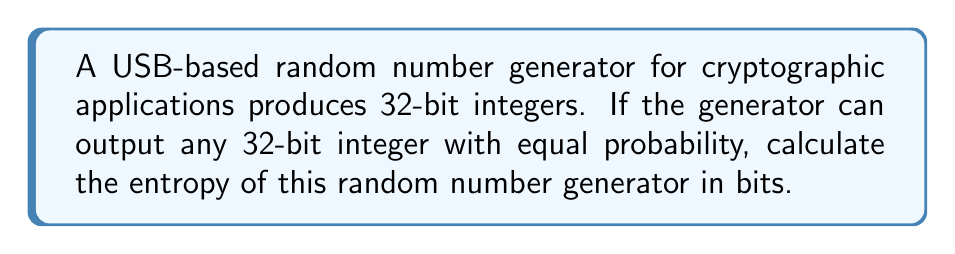Give your solution to this math problem. Let's approach this step-by-step:

1) Entropy is a measure of uncertainty or randomness in a system. For a discrete random variable, it's calculated using the formula:

   $$H = -\sum_{i=1}^n p_i \log_2(p_i)$$

   where $p_i$ is the probability of each possible outcome.

2) In this case, we have a 32-bit integer generator. This means there are $2^{32}$ possible outcomes (from 0 to $2^{32} - 1$).

3) The question states that each outcome has equal probability. So, the probability of each outcome is:

   $$p_i = \frac{1}{2^{32}}$$

4) Since all probabilities are equal, we can simplify our entropy calculation:

   $$H = -2^{32} \cdot \frac{1}{2^{32}} \log_2(\frac{1}{2^{32}})$$

5) Simplify:
   
   $$H = -\log_2(\frac{1}{2^{32}})$$

6) Using the logarithm property $\log_a(\frac{1}{x}) = -\log_a(x)$:

   $$H = \log_2(2^{32})$$

7) Using the logarithm property $\log_a(a^x) = x$:

   $$H = 32$$

Thus, the entropy of this random number generator is 32 bits.
Answer: 32 bits 